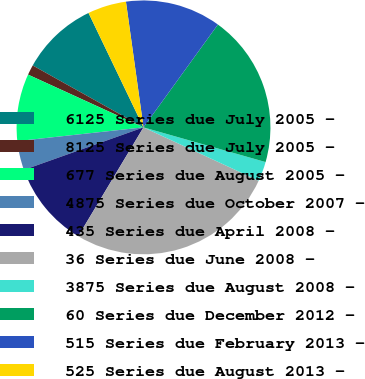Convert chart. <chart><loc_0><loc_0><loc_500><loc_500><pie_chart><fcel>6125 Series due July 2005 -<fcel>8125 Series due July 2005 -<fcel>677 Series due August 2005 -<fcel>4875 Series due October 2007 -<fcel>435 Series due April 2008 -<fcel>36 Series due June 2008 -<fcel>3875 Series due August 2008 -<fcel>60 Series due December 2012 -<fcel>515 Series due February 2013 -<fcel>525 Series due August 2013 -<nl><fcel>9.76%<fcel>1.29%<fcel>8.55%<fcel>3.71%<fcel>10.97%<fcel>26.69%<fcel>2.5%<fcel>19.44%<fcel>12.18%<fcel>4.92%<nl></chart> 